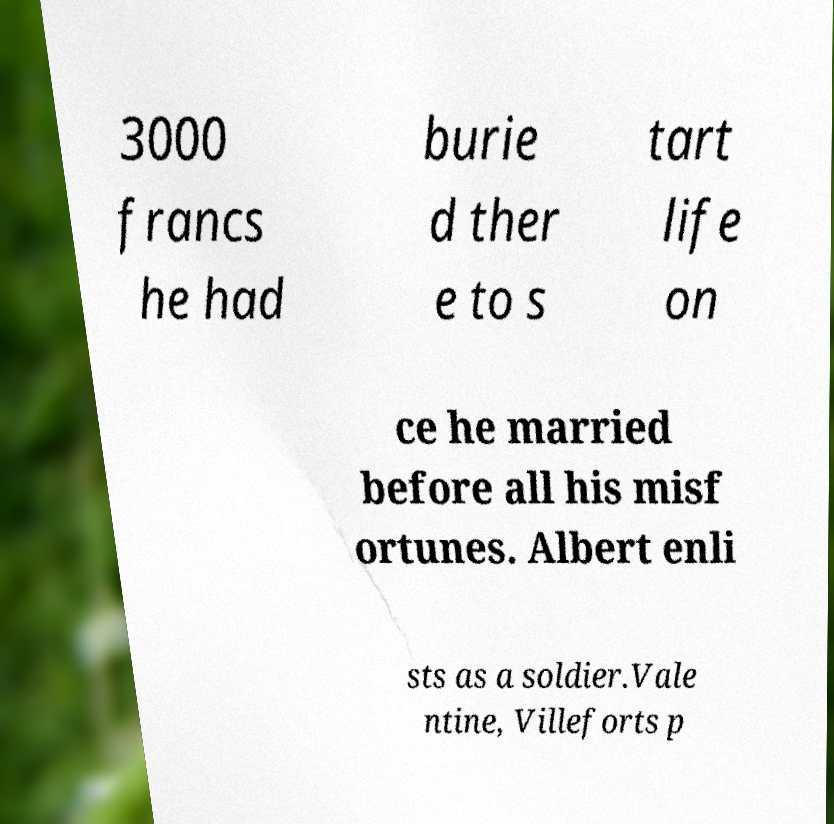Please identify and transcribe the text found in this image. 3000 francs he had burie d ther e to s tart life on ce he married before all his misf ortunes. Albert enli sts as a soldier.Vale ntine, Villeforts p 